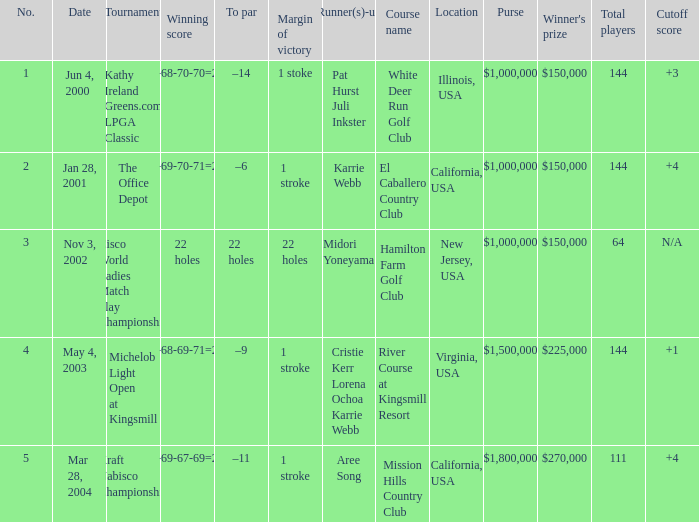What is the to par dated may 4, 2003? –9. 